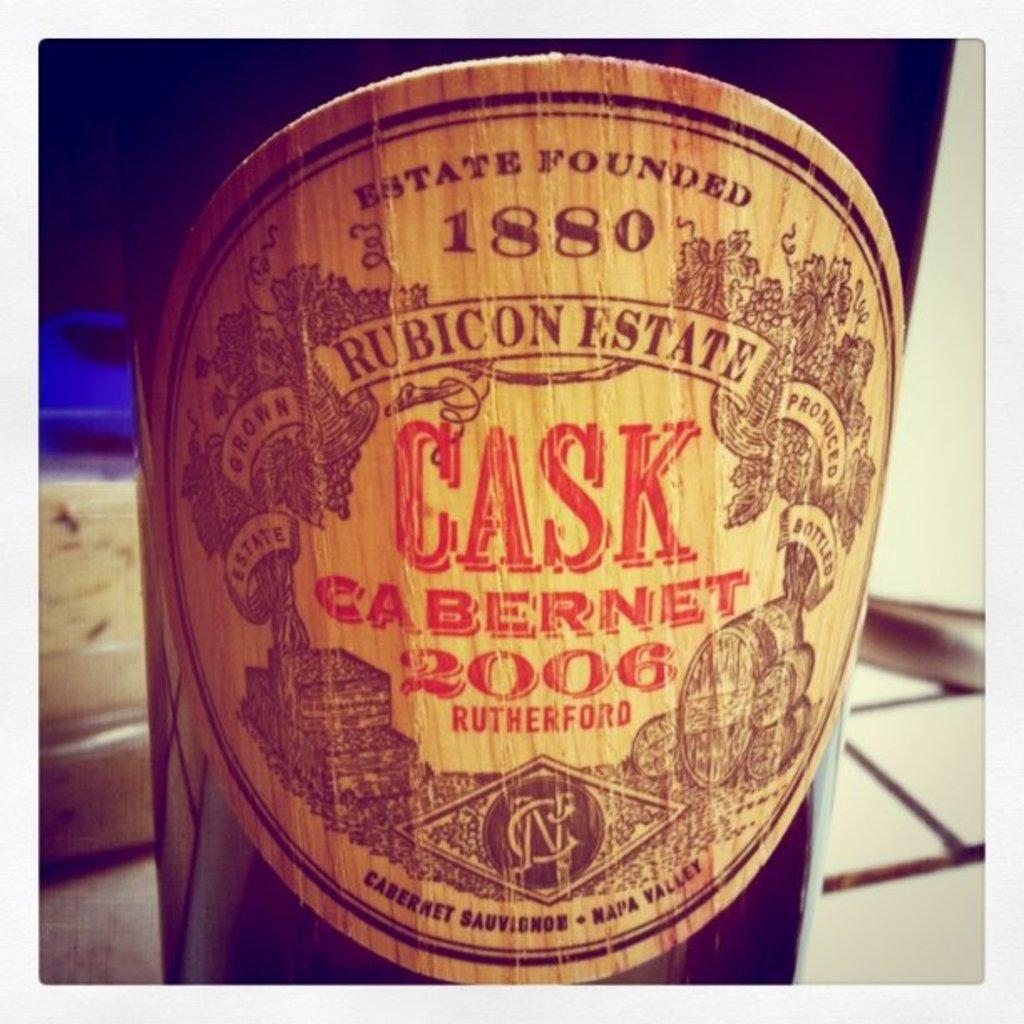<image>
Describe the image concisely. A bottle of Rubicon Estate cask Cabernet from 2006 